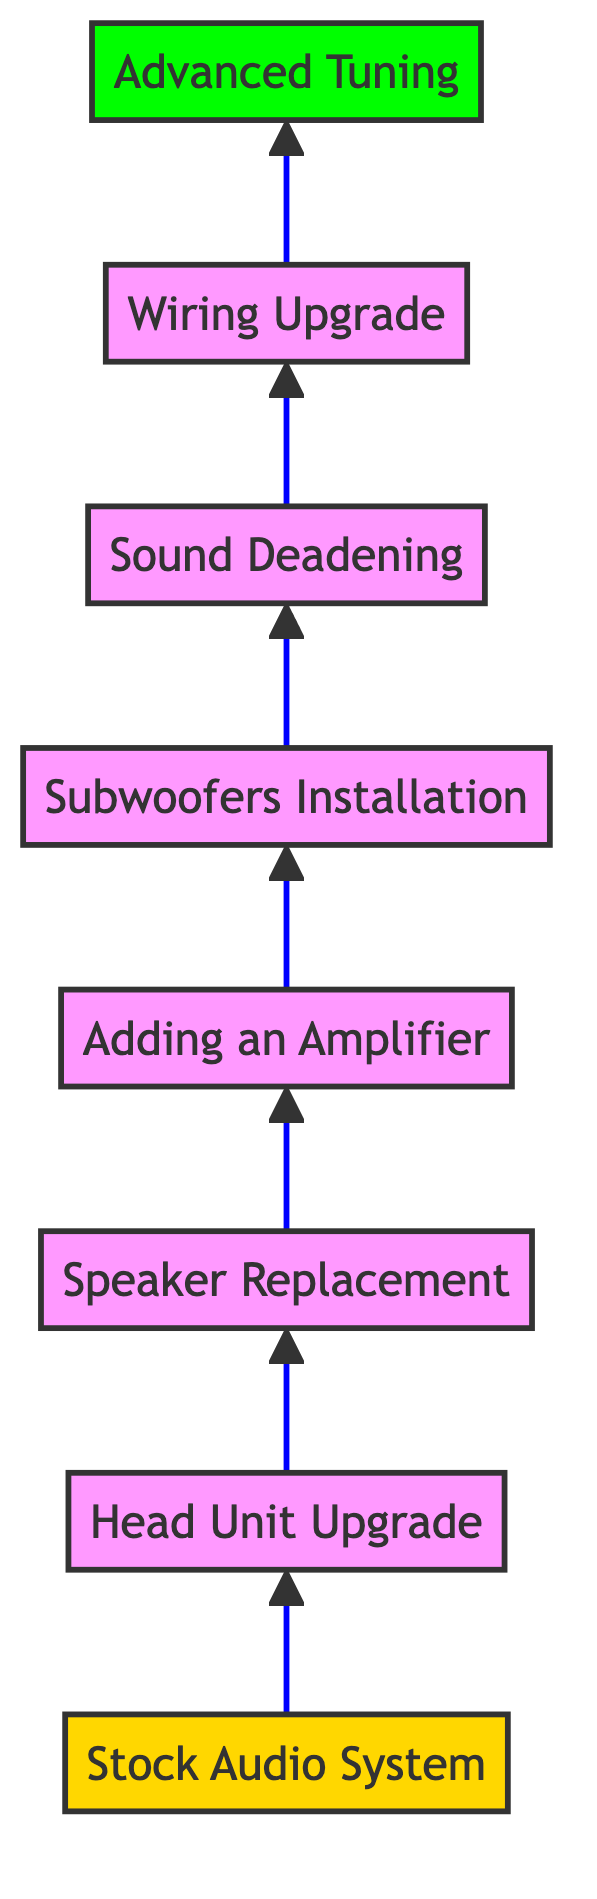What is the first step in upgrading a car audio system? The diagram starts with the "Stock Audio System" at level 1, indicating that this is the initial step before any upgrades.
Answer: Stock Audio System How many steps are there in the upgrade process? Counting from "Stock Audio System" to "Advanced Tuning," there are a total of 8 levels in the upgrade process.
Answer: 8 Which step involves adding an amplifier? The step that includes the addition of an amplifier is "Adding an Amplifier," which is the 4th level in the diagram.
Answer: Adding an Amplifier What comes after "Subwoofers Installation"? Following "Subwoofers Installation," the next step is "Sound Deadening," indicating the progression of upgrades.
Answer: Sound Deadening What is the last step in the diagram? The final step depicted in the diagram is "Advanced Tuning," which is placed at the topmost level, level 8.
Answer: Advanced Tuning In what order do the upgrades occur? The upgrades occur in a sequential order starting from the "Stock Audio System," followed by "Head Unit Upgrade," "Speaker Replacement," "Adding an Amplifier," "Subwoofers Installation," "Sound Deadening," "Wiring Upgrade," and ending with "Advanced Tuning." This top-down approach indicates a structured upgrade path.
Answer: Stock Audio System → Head Unit Upgrade → Speaker Replacement → Adding an Amplifier → Subwoofers Installation → Sound Deadening → Wiring Upgrade → Advanced Tuning Which stage focuses on improving acoustic performance? The stage dedicated to enhancing acoustic performance is "Sound Deadening," as it involves reducing road noise and vibrations for better audio quality.
Answer: Sound Deadening What is the significance of wiring upgrade in this upgrade process? The "Wiring Upgrade" stage ensures optimal power delivery and minimizes signal loss, which is crucial for achieving the best sound quality from the Kicker audio setup.
Answer: Optimal power delivery and minimized signal loss 